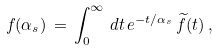<formula> <loc_0><loc_0><loc_500><loc_500>f ( \alpha _ { s } ) \, = \, \int _ { 0 } ^ { \infty } \, d t \, e ^ { - t / \alpha _ { s } } \, \widetilde { f } ( t ) \, ,</formula> 